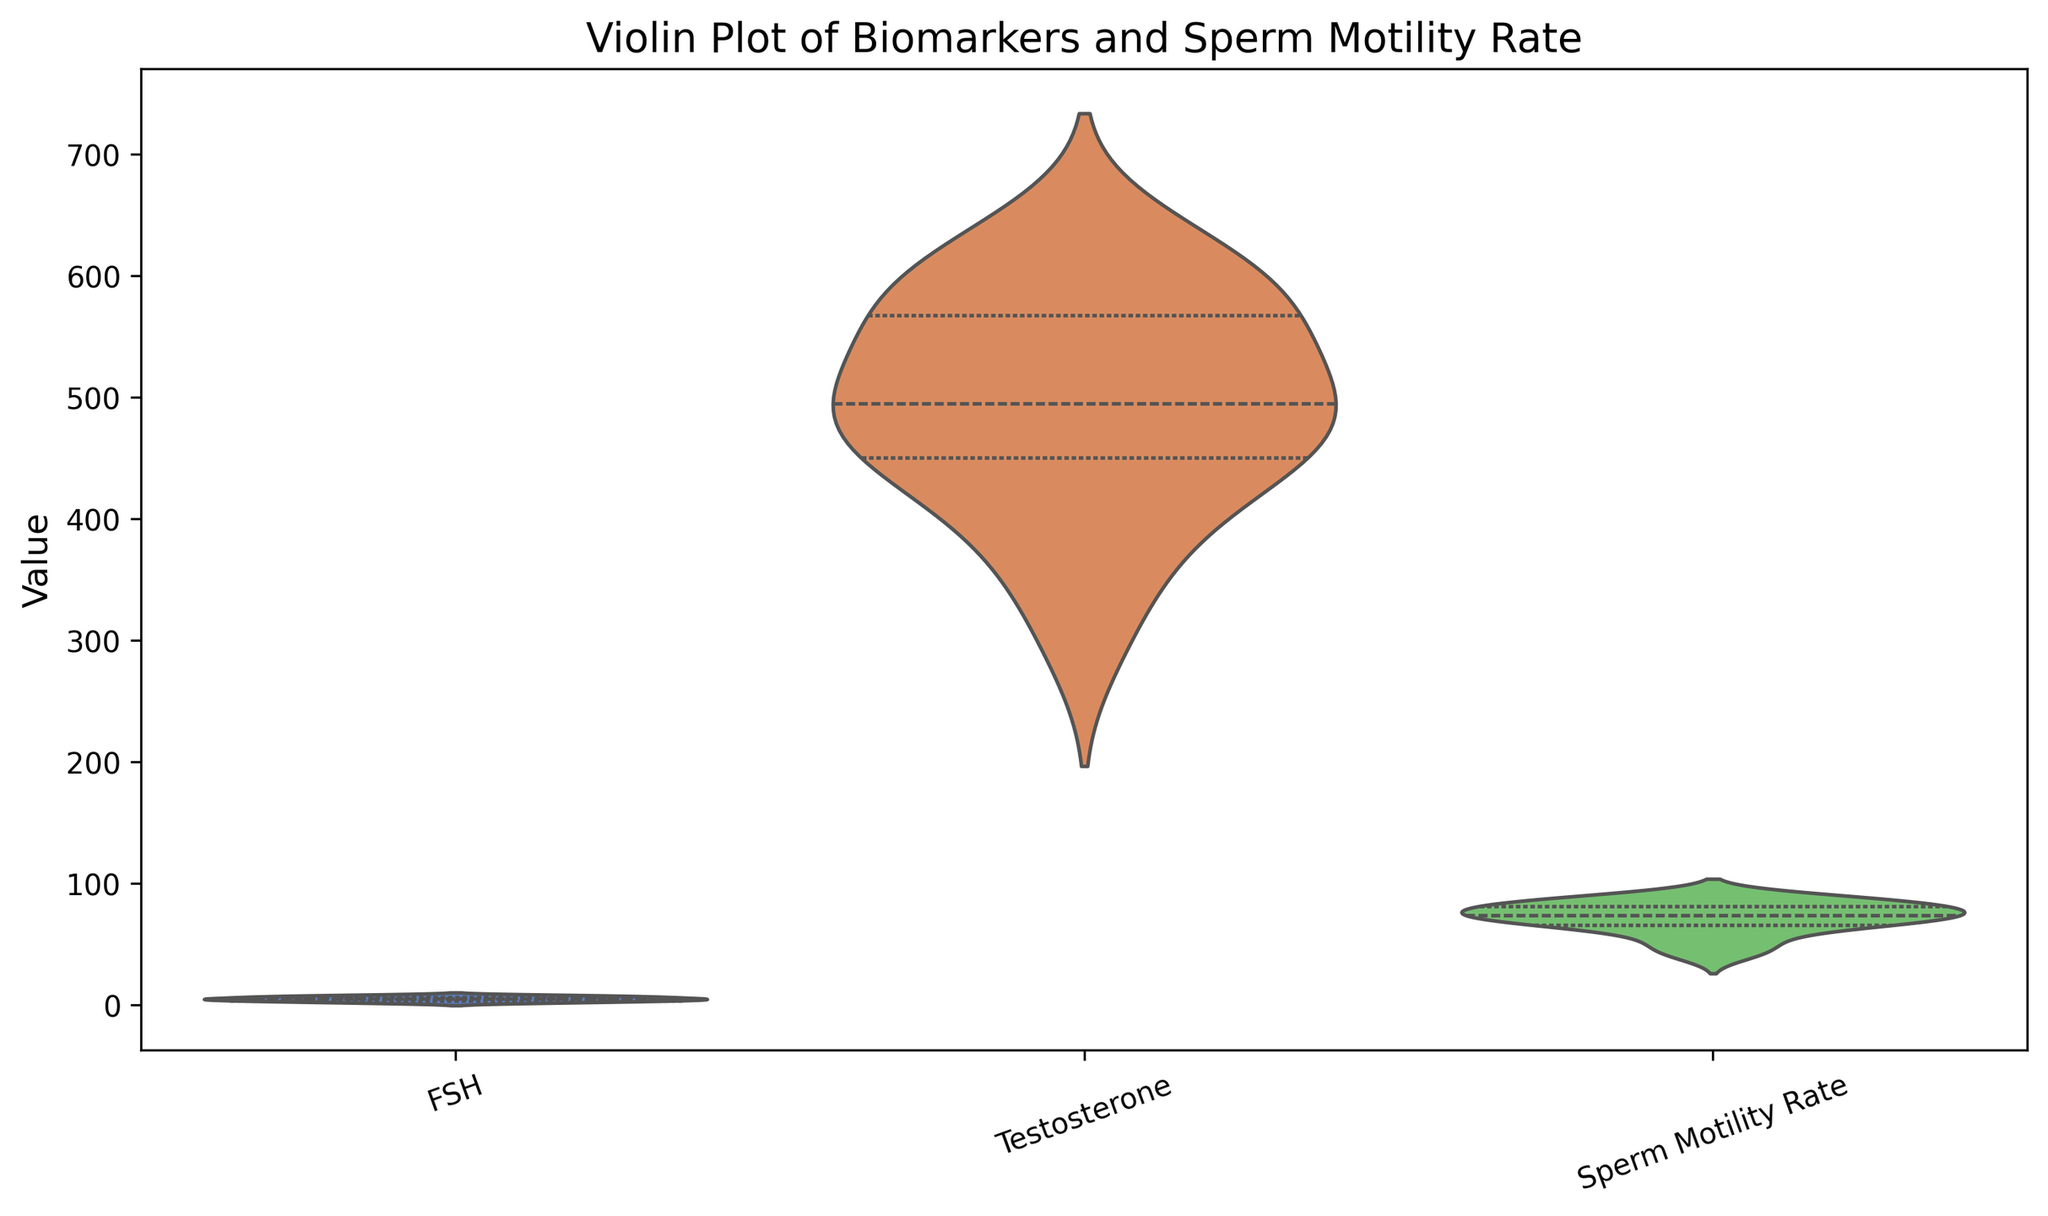Which biomarker shows the most variability? By examining the widths in the violin plot, the biomarker with the widest distribution indicates the most variability.
Answer: FSH What is the median Sperm Motility Rate? The median can be estimated by looking at the thickest part of the violin plot for Sperm Motility Rate, which represents the interquartile range and includes the median.
Answer: Around 75 Which biomarker appears to have the smallest range? The biomarker with the narrowest distribution in the violin plot has the smallest range.
Answer: Testosterone How do the interquartile ranges of Testosterone and Sperm Motility Rate compare? Look at the widths of the violin plots for the central 50% of the data, the interquartile ranges, to compare them.
Answer: Sperm Motility Rate has a wider interquartile range than Testosterone Are there any biomarkers with significant outliers? This can be identified by the long tails or points outside the main body of the violin plots.
Answer: No significant outliers Which biomarker has its highest density closest to a value of 50? The highest density is where the violin plot is widest. For this question, we look at the portions near 50 for each biomarker.
Answer: None Between FSH and Sperm Motility Rate, which has a higher maximum value visible in the plot? The highest point observed on each plot indicates the maximum value.
Answer: FSH Is there any overlap in the interquartile ranges of FSH and Sperm Motility Rate? Examine if the thick sections in the center of the violins for FSH and Sperm Motility Rate intersect or not.
Answer: Yes How does the spread of Testosterone values compare to Sperm Motility Rate? The spread is indicated by how wide the violin plot is across its length. Comparing the overall widths will give the required insight.
Answer: Testosterone has a smaller spread than Sperm Motility Rate 